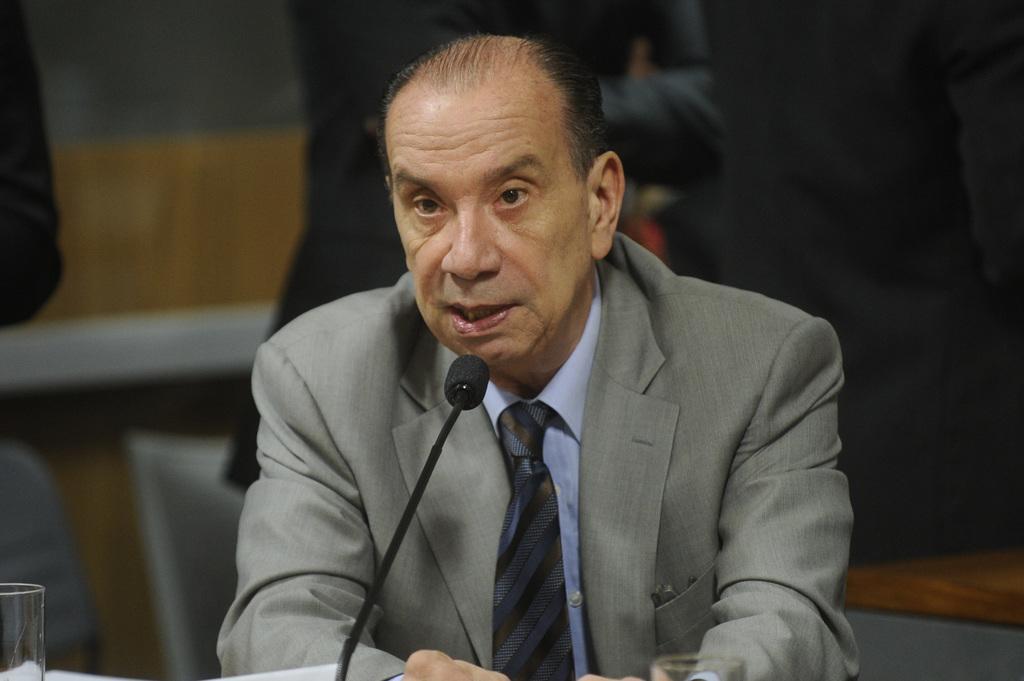Can you describe this image briefly? In the center of the image, we can see a person wearing a coat and a tie and there is a mic and a glass on the stand. In the background, there are people and we can see a wall. 